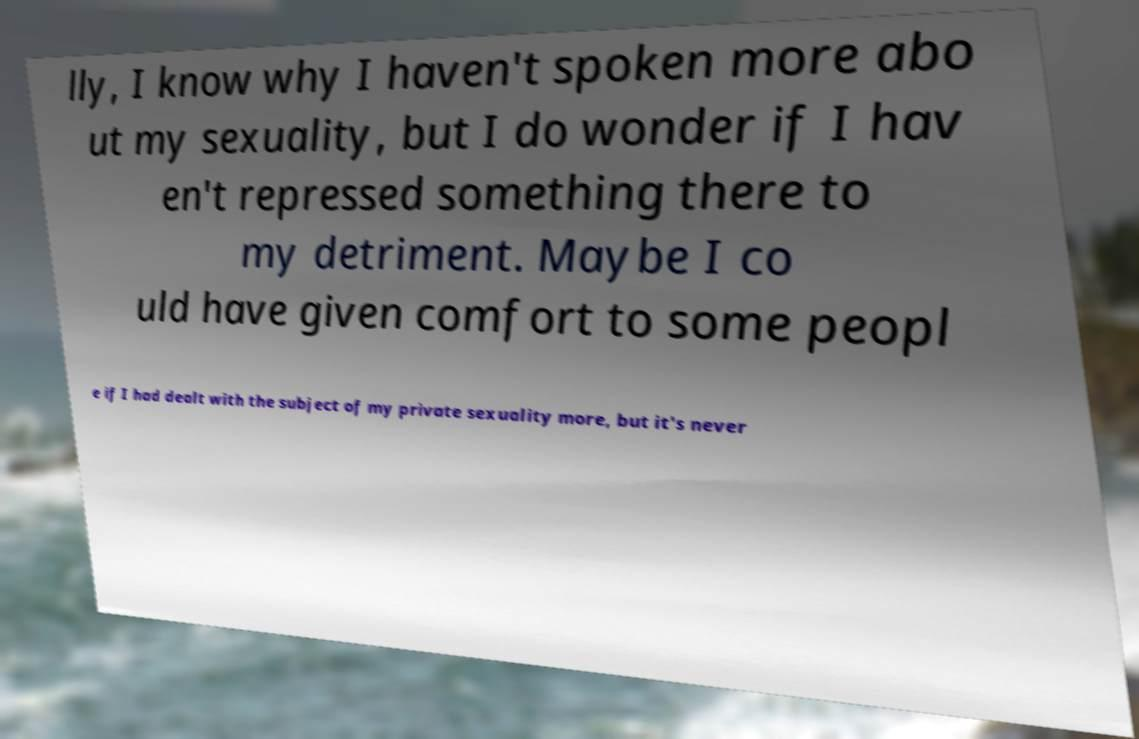Please read and relay the text visible in this image. What does it say? lly, I know why I haven't spoken more abo ut my sexuality, but I do wonder if I hav en't repressed something there to my detriment. Maybe I co uld have given comfort to some peopl e if I had dealt with the subject of my private sexuality more, but it's never 